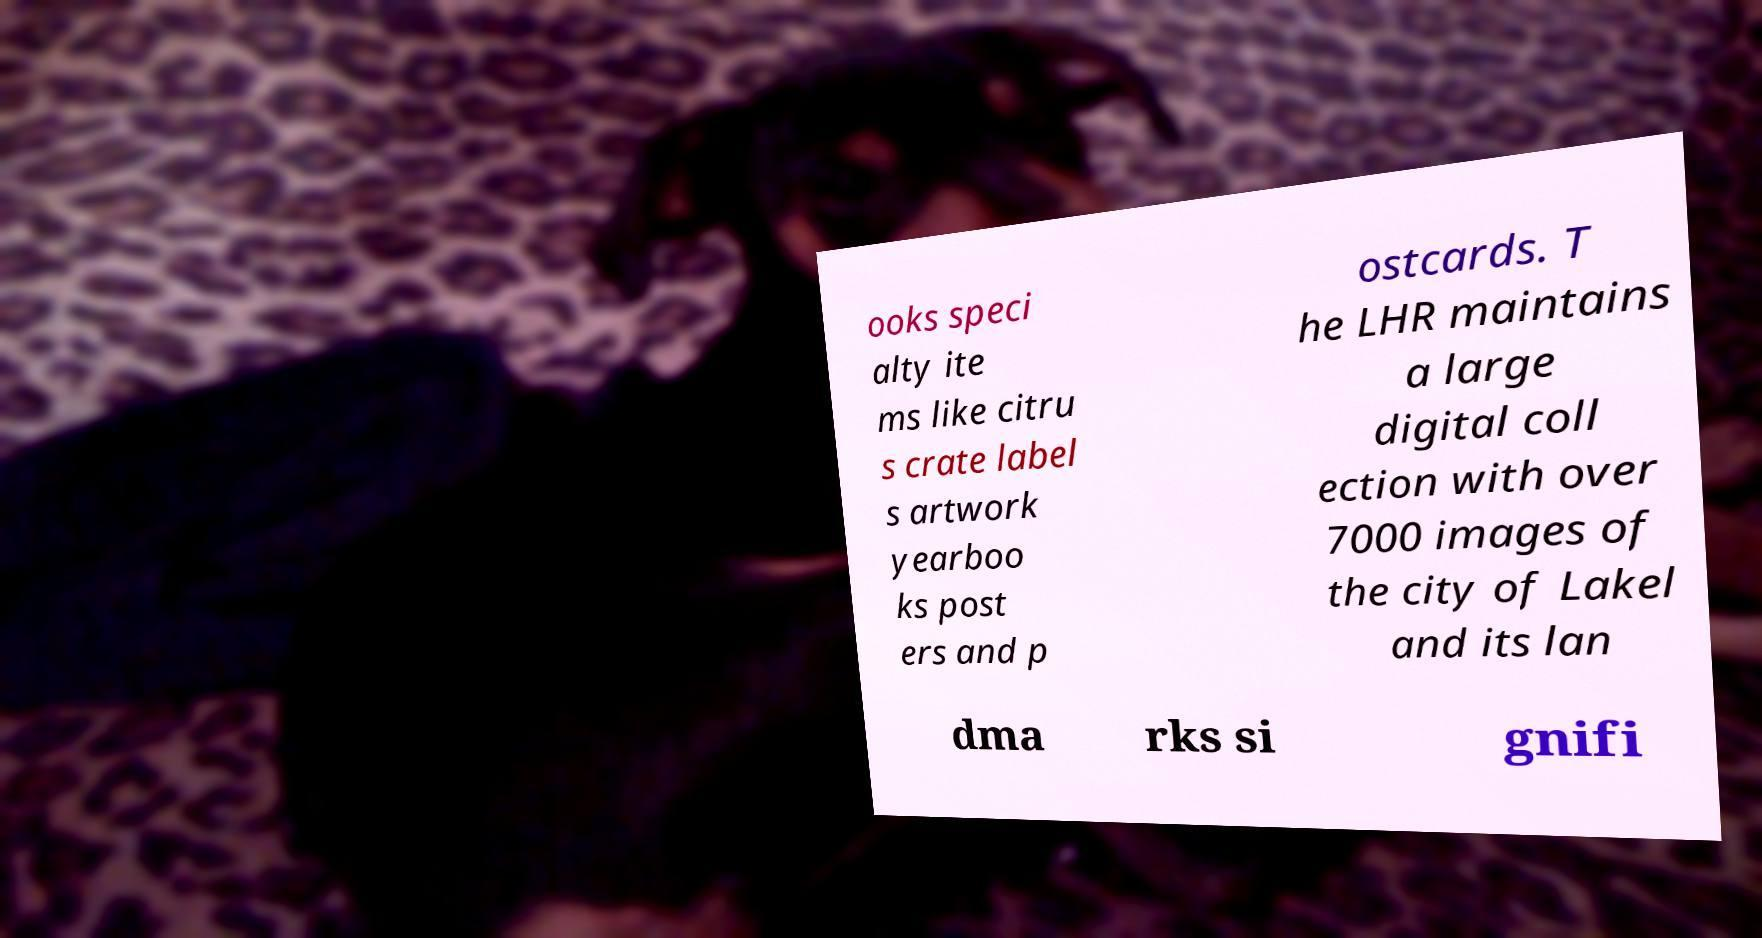Please identify and transcribe the text found in this image. ooks speci alty ite ms like citru s crate label s artwork yearboo ks post ers and p ostcards. T he LHR maintains a large digital coll ection with over 7000 images of the city of Lakel and its lan dma rks si gnifi 